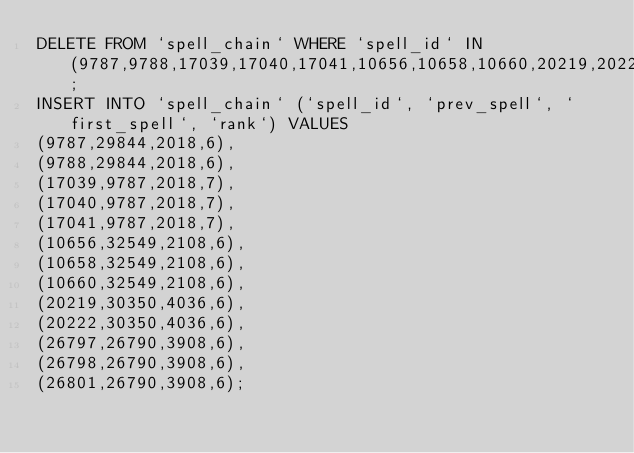Convert code to text. <code><loc_0><loc_0><loc_500><loc_500><_SQL_>DELETE FROM `spell_chain` WHERE `spell_id` IN (9787,9788,17039,17040,17041,10656,10658,10660,20219,20222,26797,26798,26801);
INSERT INTO `spell_chain` (`spell_id`, `prev_spell`, `first_spell`, `rank`) VALUES
(9787,29844,2018,6),
(9788,29844,2018,6),
(17039,9787,2018,7),
(17040,9787,2018,7),
(17041,9787,2018,7),
(10656,32549,2108,6),
(10658,32549,2108,6),
(10660,32549,2108,6),
(20219,30350,4036,6),
(20222,30350,4036,6),
(26797,26790,3908,6),
(26798,26790,3908,6),
(26801,26790,3908,6);
</code> 